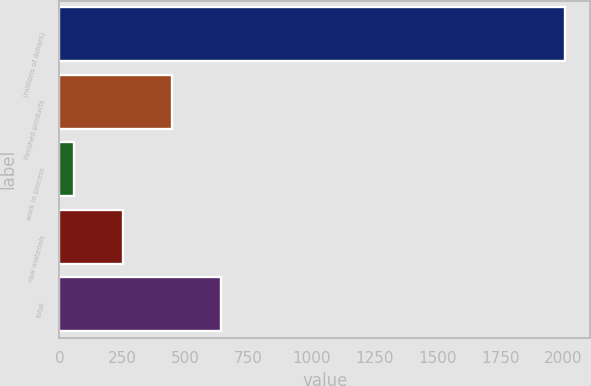Convert chart to OTSL. <chart><loc_0><loc_0><loc_500><loc_500><bar_chart><fcel>(millions of dollars)<fcel>Finished products<fcel>work in process<fcel>raw materials<fcel>total<nl><fcel>2007<fcel>447.56<fcel>57.7<fcel>252.63<fcel>642.49<nl></chart> 